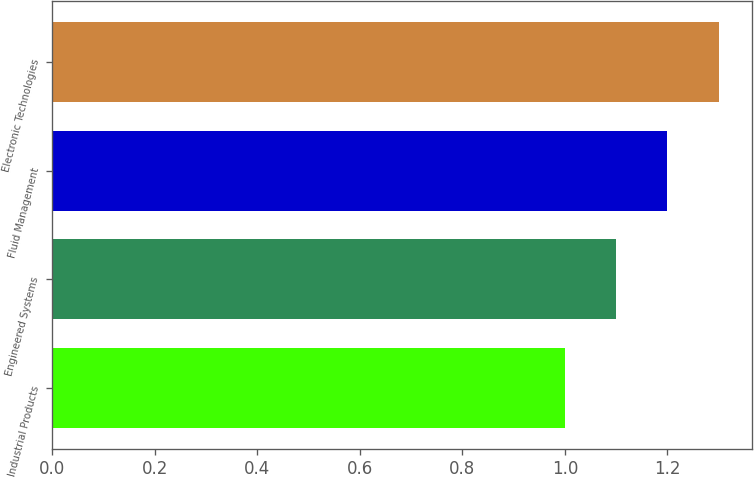<chart> <loc_0><loc_0><loc_500><loc_500><bar_chart><fcel>Industrial Products<fcel>Engineered Systems<fcel>Fluid Management<fcel>Electronic Technologies<nl><fcel>1<fcel>1.1<fcel>1.2<fcel>1.3<nl></chart> 